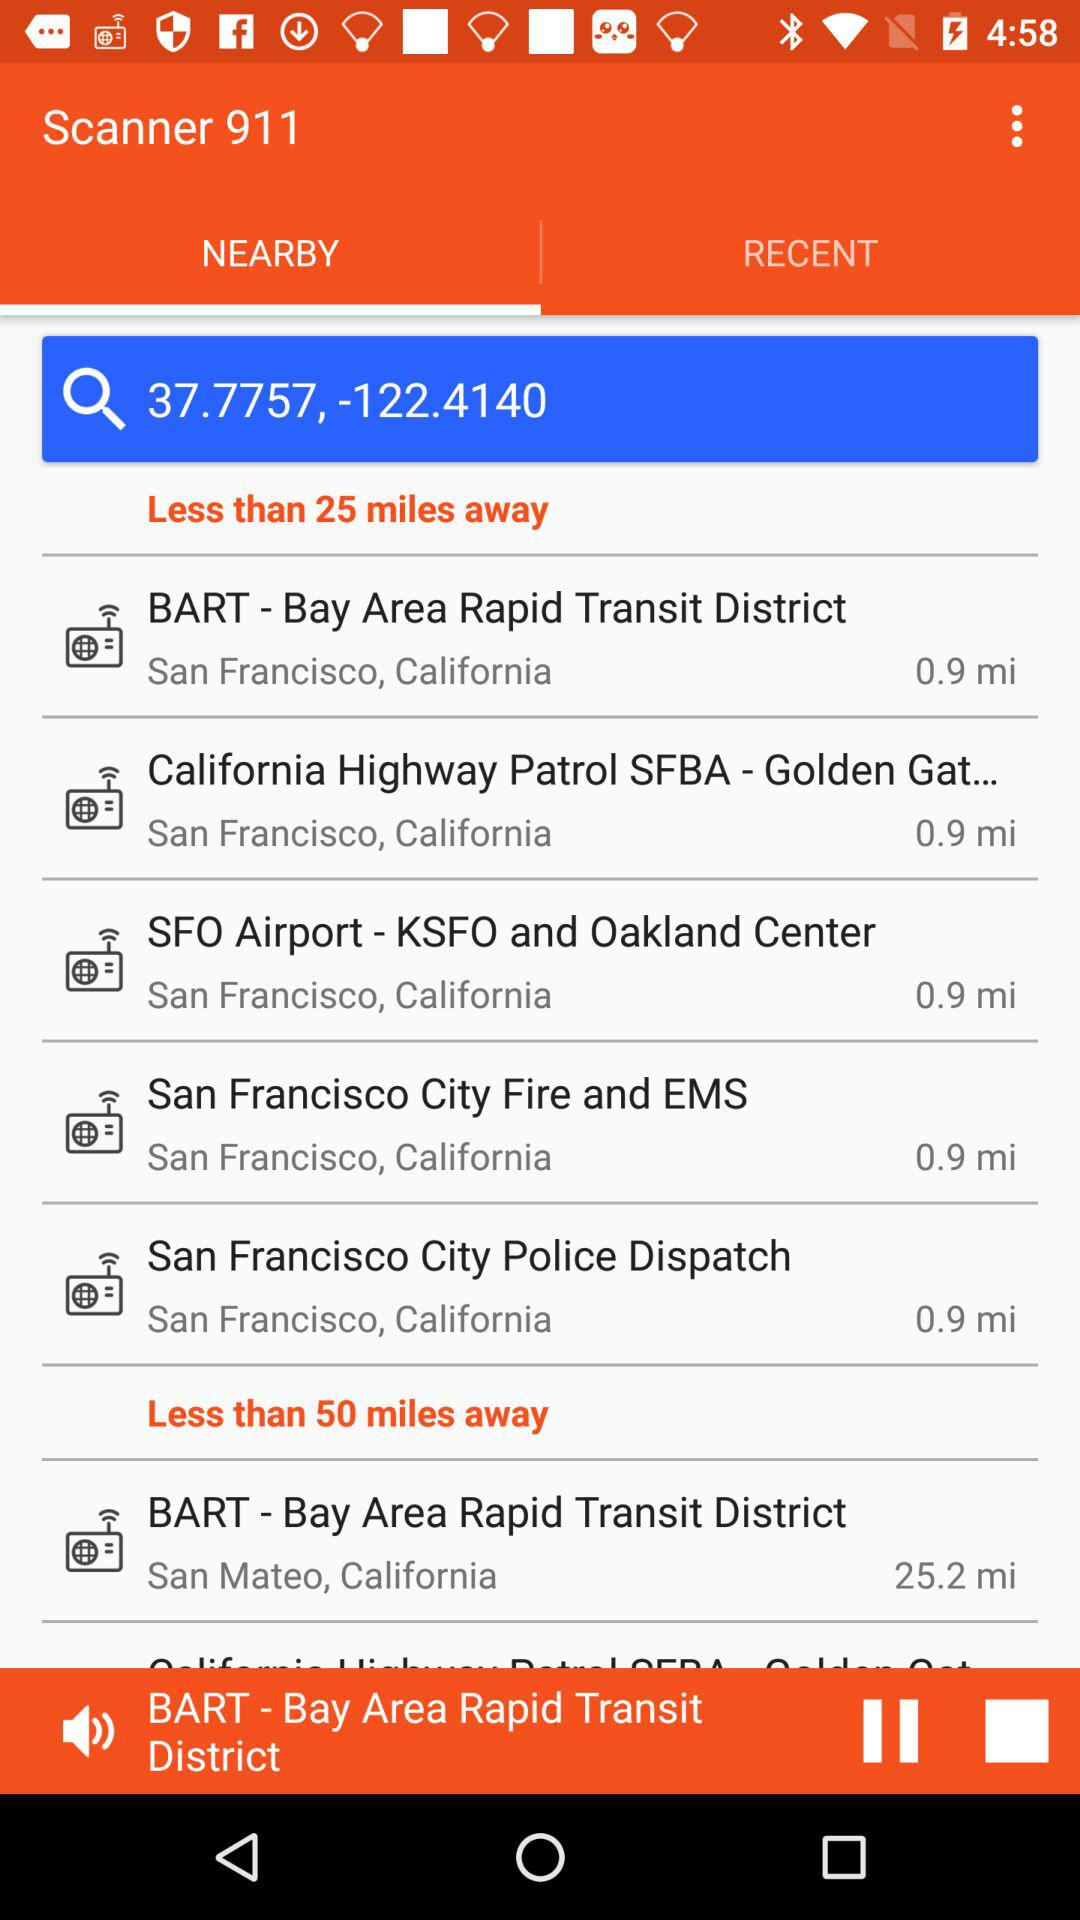How many miles away is the scanner of BART in San Mateo? The scanner of BART in San Mateo is 25.2 miles away. 